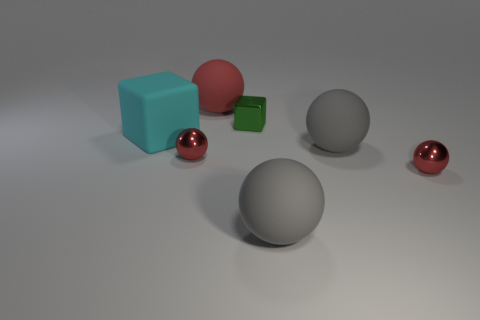What textures are present among the objects in this image? In the image, we see a variety of textures. The big cyan cube and the smaller green cube have a matte plastic texture. The large grey sphere and the smaller red sphere in the foreground also have a matte finish but appear to be metallic. In contrast, the large red sphere has a polished, reflective metallic surface. 